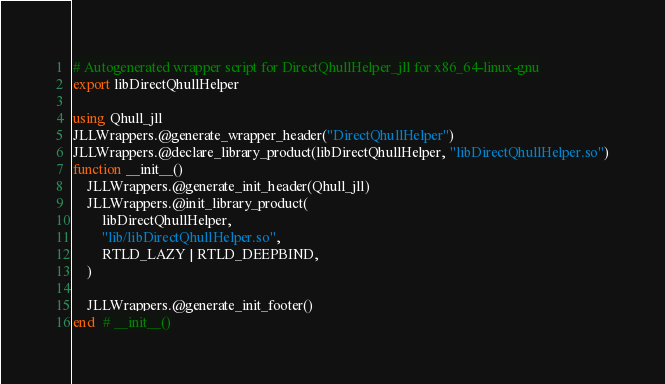Convert code to text. <code><loc_0><loc_0><loc_500><loc_500><_Julia_># Autogenerated wrapper script for DirectQhullHelper_jll for x86_64-linux-gnu
export libDirectQhullHelper

using Qhull_jll
JLLWrappers.@generate_wrapper_header("DirectQhullHelper")
JLLWrappers.@declare_library_product(libDirectQhullHelper, "libDirectQhullHelper.so")
function __init__()
    JLLWrappers.@generate_init_header(Qhull_jll)
    JLLWrappers.@init_library_product(
        libDirectQhullHelper,
        "lib/libDirectQhullHelper.so",
        RTLD_LAZY | RTLD_DEEPBIND,
    )

    JLLWrappers.@generate_init_footer()
end  # __init__()
</code> 